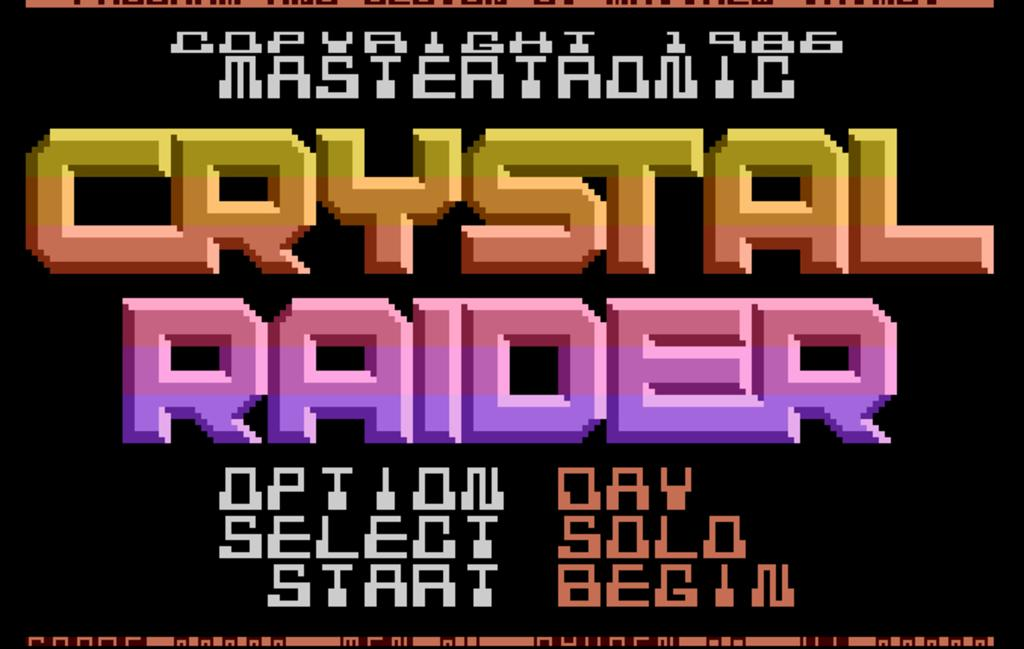Provide a one-sentence caption for the provided image. A screen for Crystal Raider gives options to play the game. 